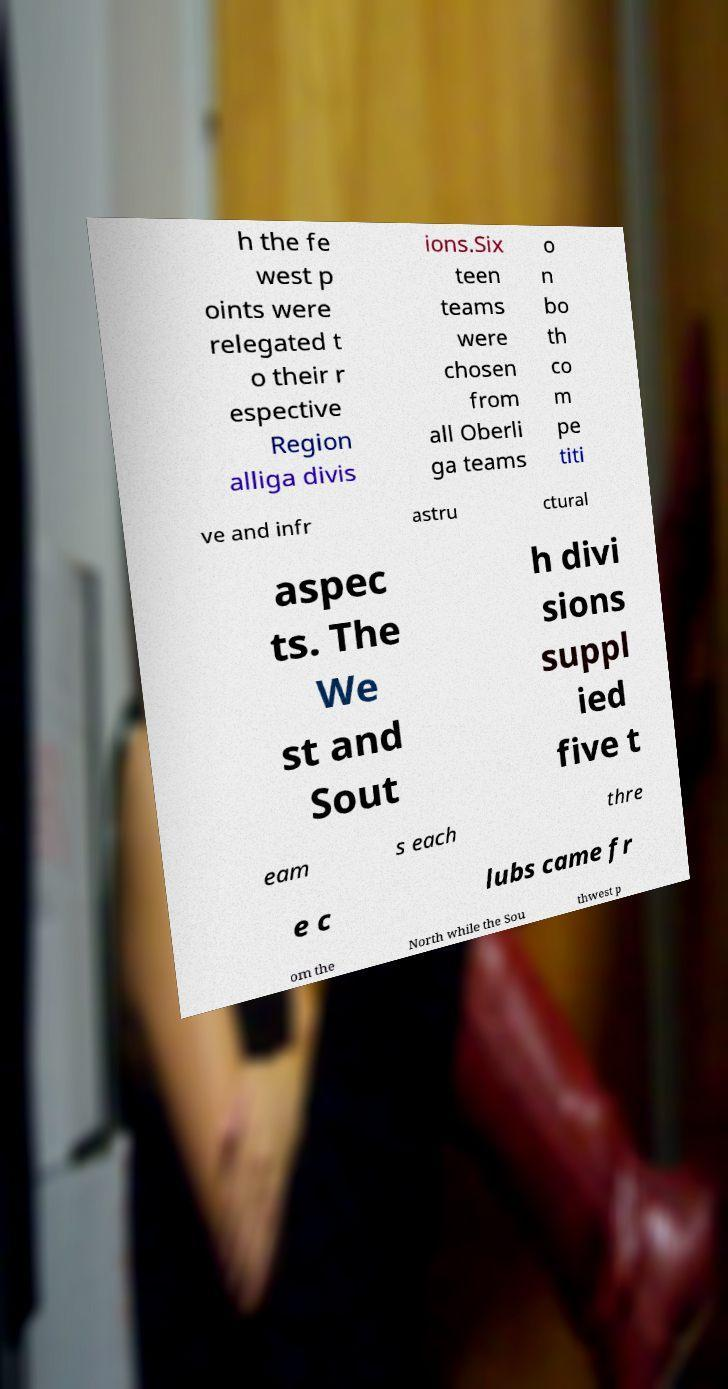There's text embedded in this image that I need extracted. Can you transcribe it verbatim? h the fe west p oints were relegated t o their r espective Region alliga divis ions.Six teen teams were chosen from all Oberli ga teams o n bo th co m pe titi ve and infr astru ctural aspec ts. The We st and Sout h divi sions suppl ied five t eam s each thre e c lubs came fr om the North while the Sou thwest p 